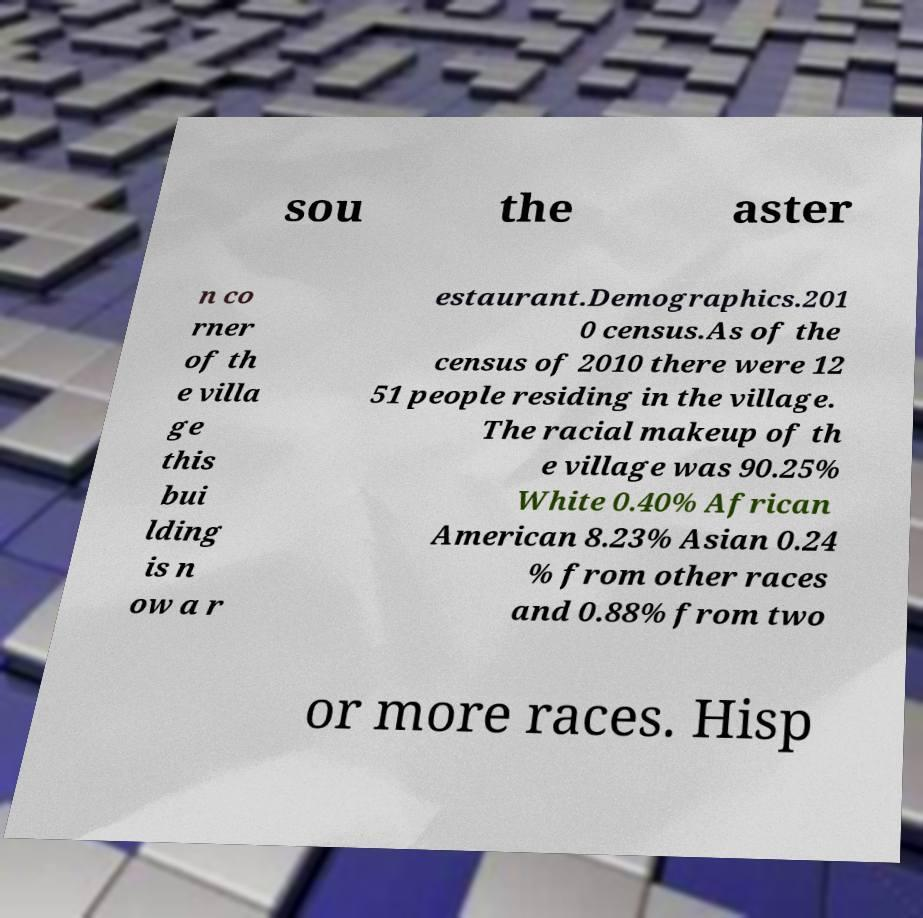Please read and relay the text visible in this image. What does it say? sou the aster n co rner of th e villa ge this bui lding is n ow a r estaurant.Demographics.201 0 census.As of the census of 2010 there were 12 51 people residing in the village. The racial makeup of th e village was 90.25% White 0.40% African American 8.23% Asian 0.24 % from other races and 0.88% from two or more races. Hisp 